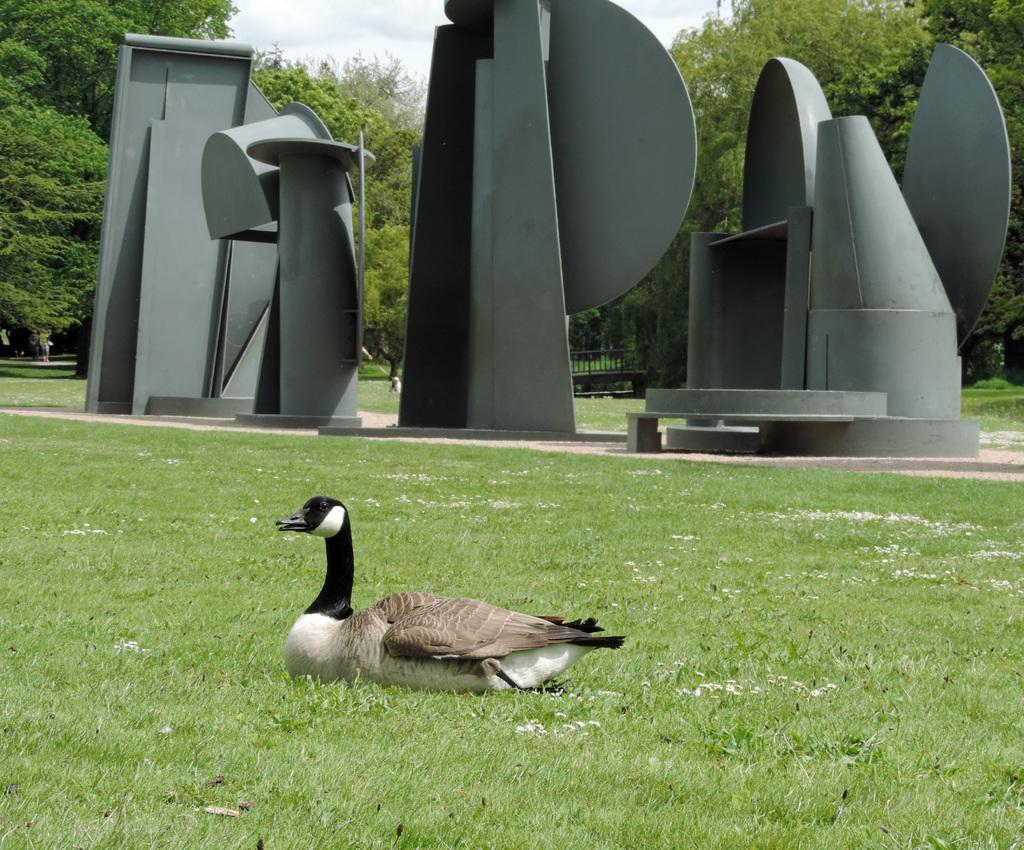What type of animal can be seen in the image? There is a bird in the image. What is the surface beneath the bird? The ground is visible in the image. What type of vegetation is present in the image? There is grass in the image. What type of natural features can be seen in the image? There are trees in the image. What type of man-made structures can be seen in the image? There are structures in the image. What type of barrier is present in the image? There is a fence in the image. What is visible above the structures and trees in the image? The sky is visible in the image. What type of harbor can be seen in the image? There is no harbor present in the image. How does the bird transport itself in the image? The bird does not transport itself in the image; it is stationary. What part of the brain can be seen in the image? There is no brain present in the image. 